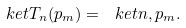Convert formula to latex. <formula><loc_0><loc_0><loc_500><loc_500>\ k e t { T _ { n } ( p _ { m } ) } = \ k e t { n , p _ { m } } .</formula> 